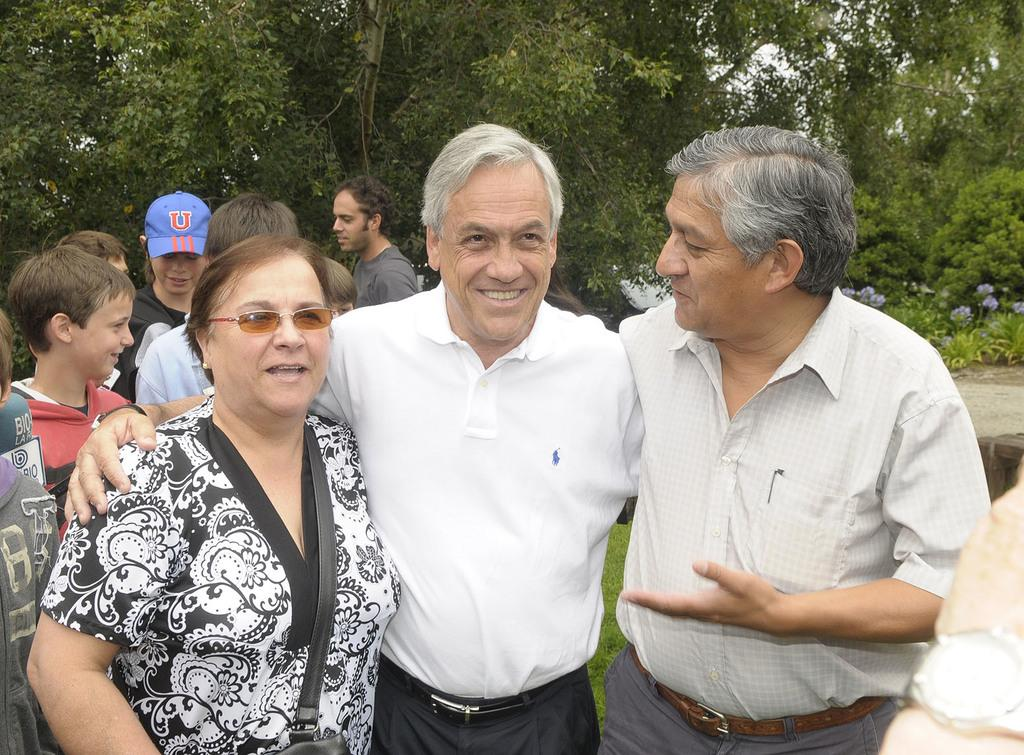How many people are present in the image? There are many people in the image. Can you describe the attire of one of the ladies in the image? One lady is wearing a cap. What accessory is worn by another lady in the image? Another lady is wearing glasses (specs). What type of vegetation can be seen in the background of the image? There are trees and plants with flowers in the background of the image. What type of quartz can be seen in the image? There is no quartz present in the image. How does the feeling of the people in the image change throughout the day? The image does not provide information about the feelings of the people or how they change throughout the day. 